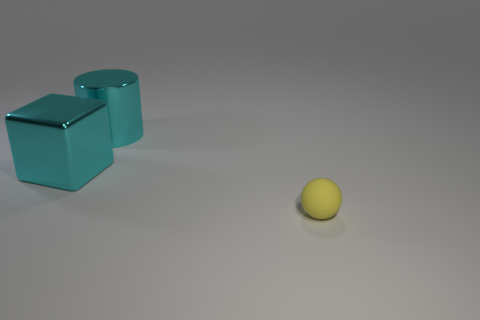Add 3 big blue metal objects. How many objects exist? 6 Subtract all cylinders. How many objects are left? 2 Subtract 0 yellow cubes. How many objects are left? 3 Subtract all large blue matte cubes. Subtract all big cyan metal objects. How many objects are left? 1 Add 1 yellow spheres. How many yellow spheres are left? 2 Add 1 large cyan shiny cylinders. How many large cyan shiny cylinders exist? 2 